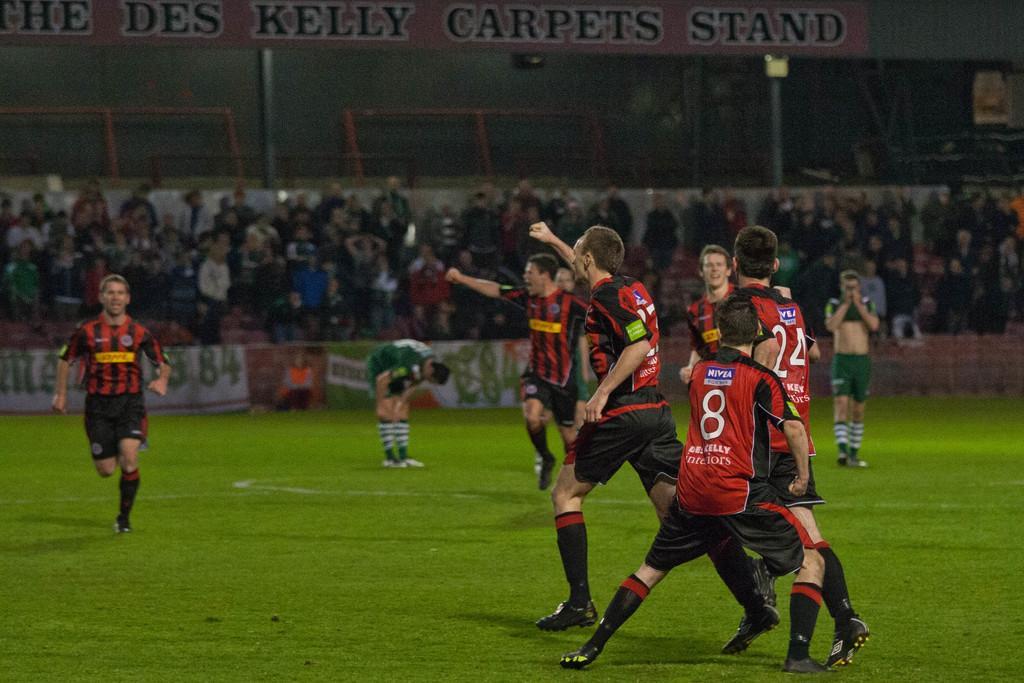Describe this image in one or two sentences. This picture might be taken in a stadium, in this picture in the center there are some people who are walking and some of them are screaming. In the background there are some people who are standing, and there is a board. At the bottom there is grass and on the top of the image there are some poles and boards. 